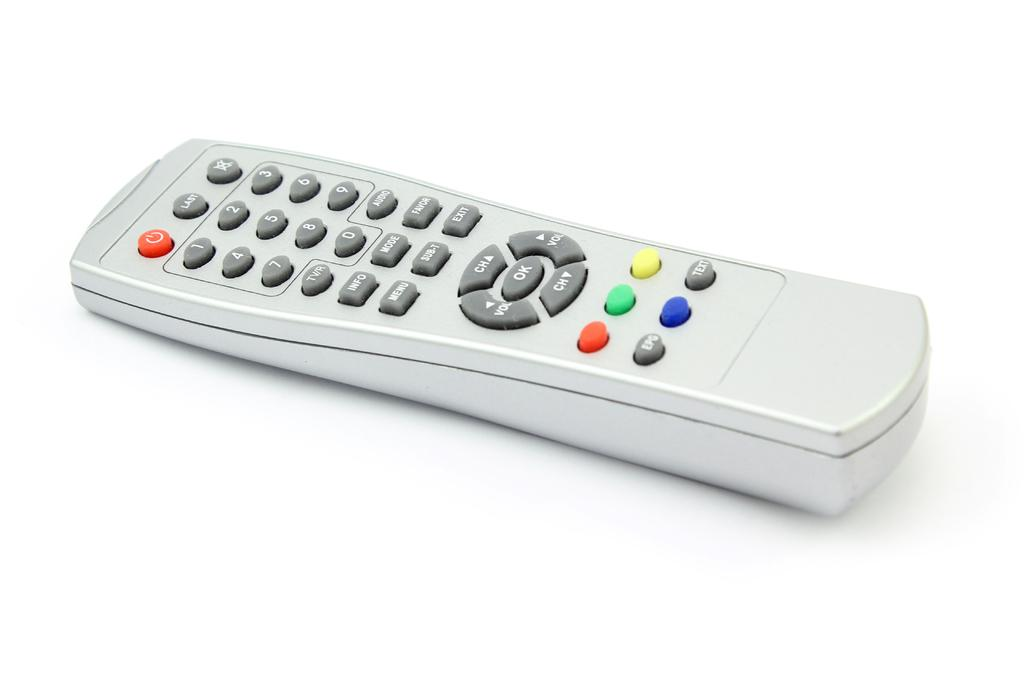<image>
Provide a brief description of the given image. Gray controller with multicolored buttons and the "TEXT" button on the bottom. 